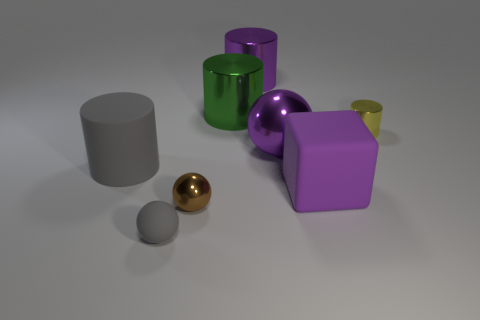Add 2 red matte things. How many objects exist? 10 Subtract all blocks. How many objects are left? 7 Subtract 0 blue cylinders. How many objects are left? 8 Subtract all matte blocks. Subtract all gray objects. How many objects are left? 5 Add 2 big purple metallic spheres. How many big purple metallic spheres are left? 3 Add 3 big gray matte cylinders. How many big gray matte cylinders exist? 4 